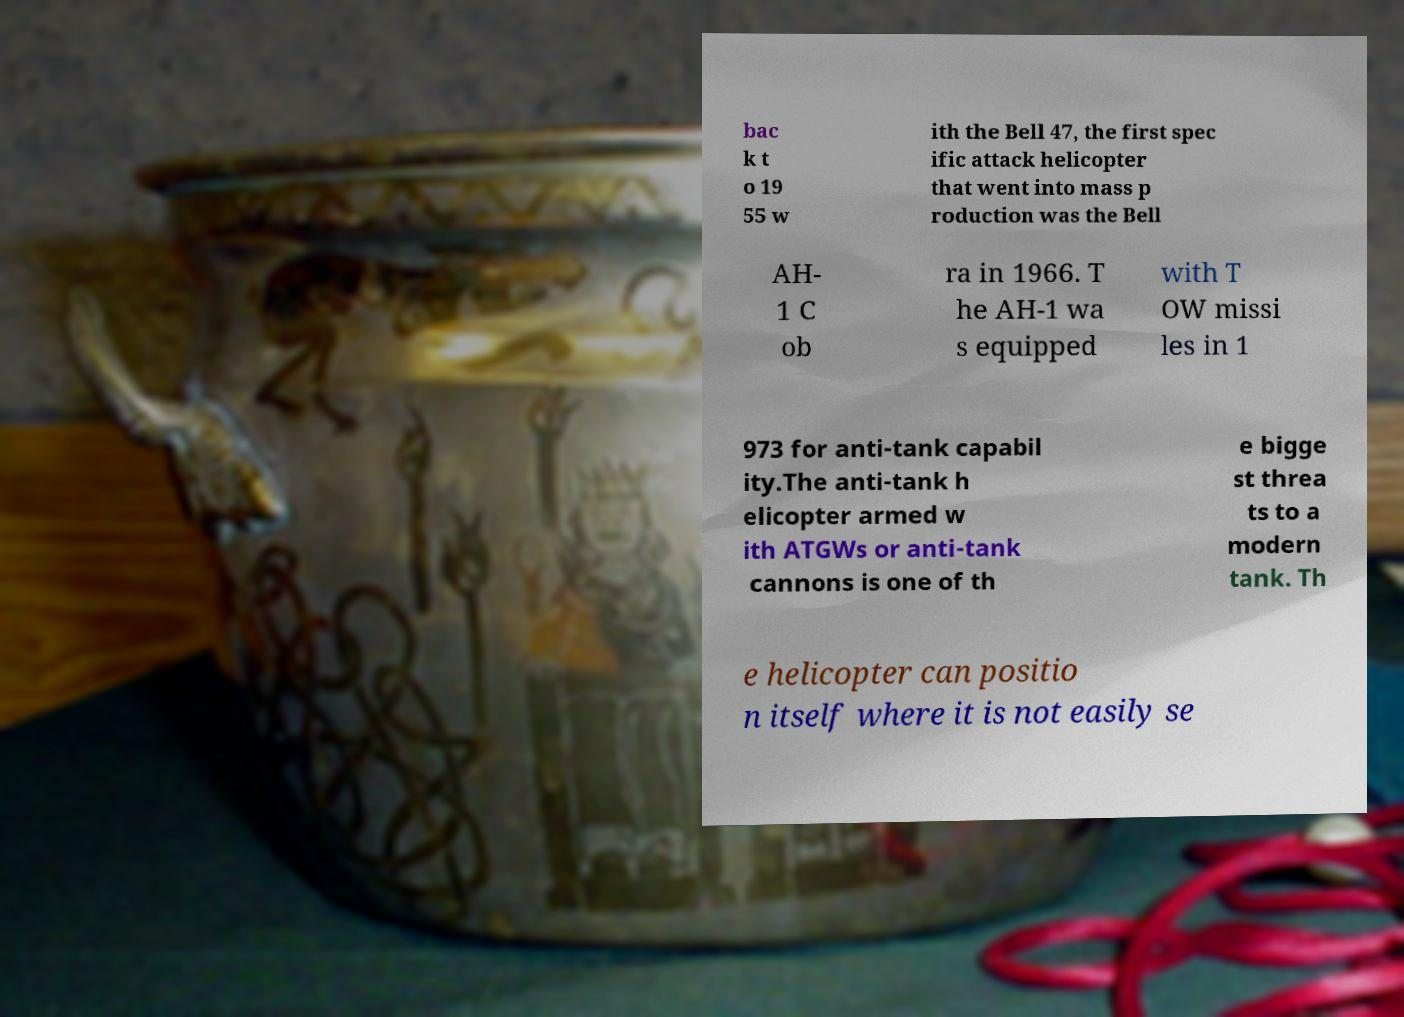Could you assist in decoding the text presented in this image and type it out clearly? bac k t o 19 55 w ith the Bell 47, the first spec ific attack helicopter that went into mass p roduction was the Bell AH- 1 C ob ra in 1966. T he AH-1 wa s equipped with T OW missi les in 1 973 for anti-tank capabil ity.The anti-tank h elicopter armed w ith ATGWs or anti-tank cannons is one of th e bigge st threa ts to a modern tank. Th e helicopter can positio n itself where it is not easily se 